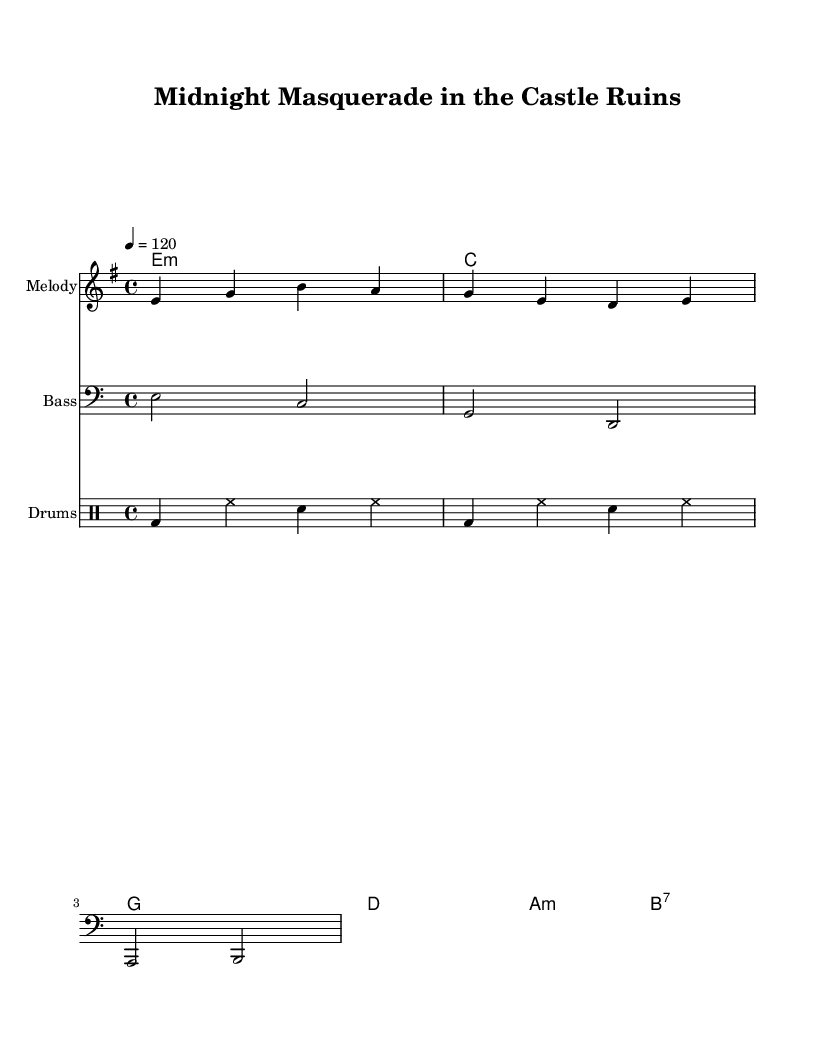What is the key signature of this music? The key signature is indicated by the sharp or flat symbols at the beginning of the staff. This piece is in E minor, which has one sharp.
Answer: E minor What is the time signature of this music? The time signature is represented by the numbers at the beginning of the piece, following the key signature. In this case, it is 4/4, meaning there are four beats per measure.
Answer: 4/4 What is the tempo marking for this music? The tempo marking is indicated in beats per minute; here it shows 4 equals 120, signifying the speed of the piece, which is moderate disco tempo.
Answer: 120 How many measures are written for the melody? By counting the vertical lines in the melody part, which represent the end of measures, we find there are four measures in total.
Answer: 4 What type of chords are used in the harmonies? The harmony section shows various chord types; for instance, the first chord is a minor chord (E minor) and includes a mix of major and minor chords, commonly found in disco music.
Answer: Minor and Major Which drum pattern is used in this piece? The drum pattern consists of bass drum, hi-hat, and snare, as indicated in the drummode section. This pattern is typical for disco music as it provides a steady danceable rhythm.
Answer: Bass, Hi-Hat, Snare What is the instrument marking for the bass section? The instrument marking for the bass section indicates that it uses the bass clef, which is shown at the beginning of the bass staff. This is important for identifying the lower pitches.
Answer: Bass 